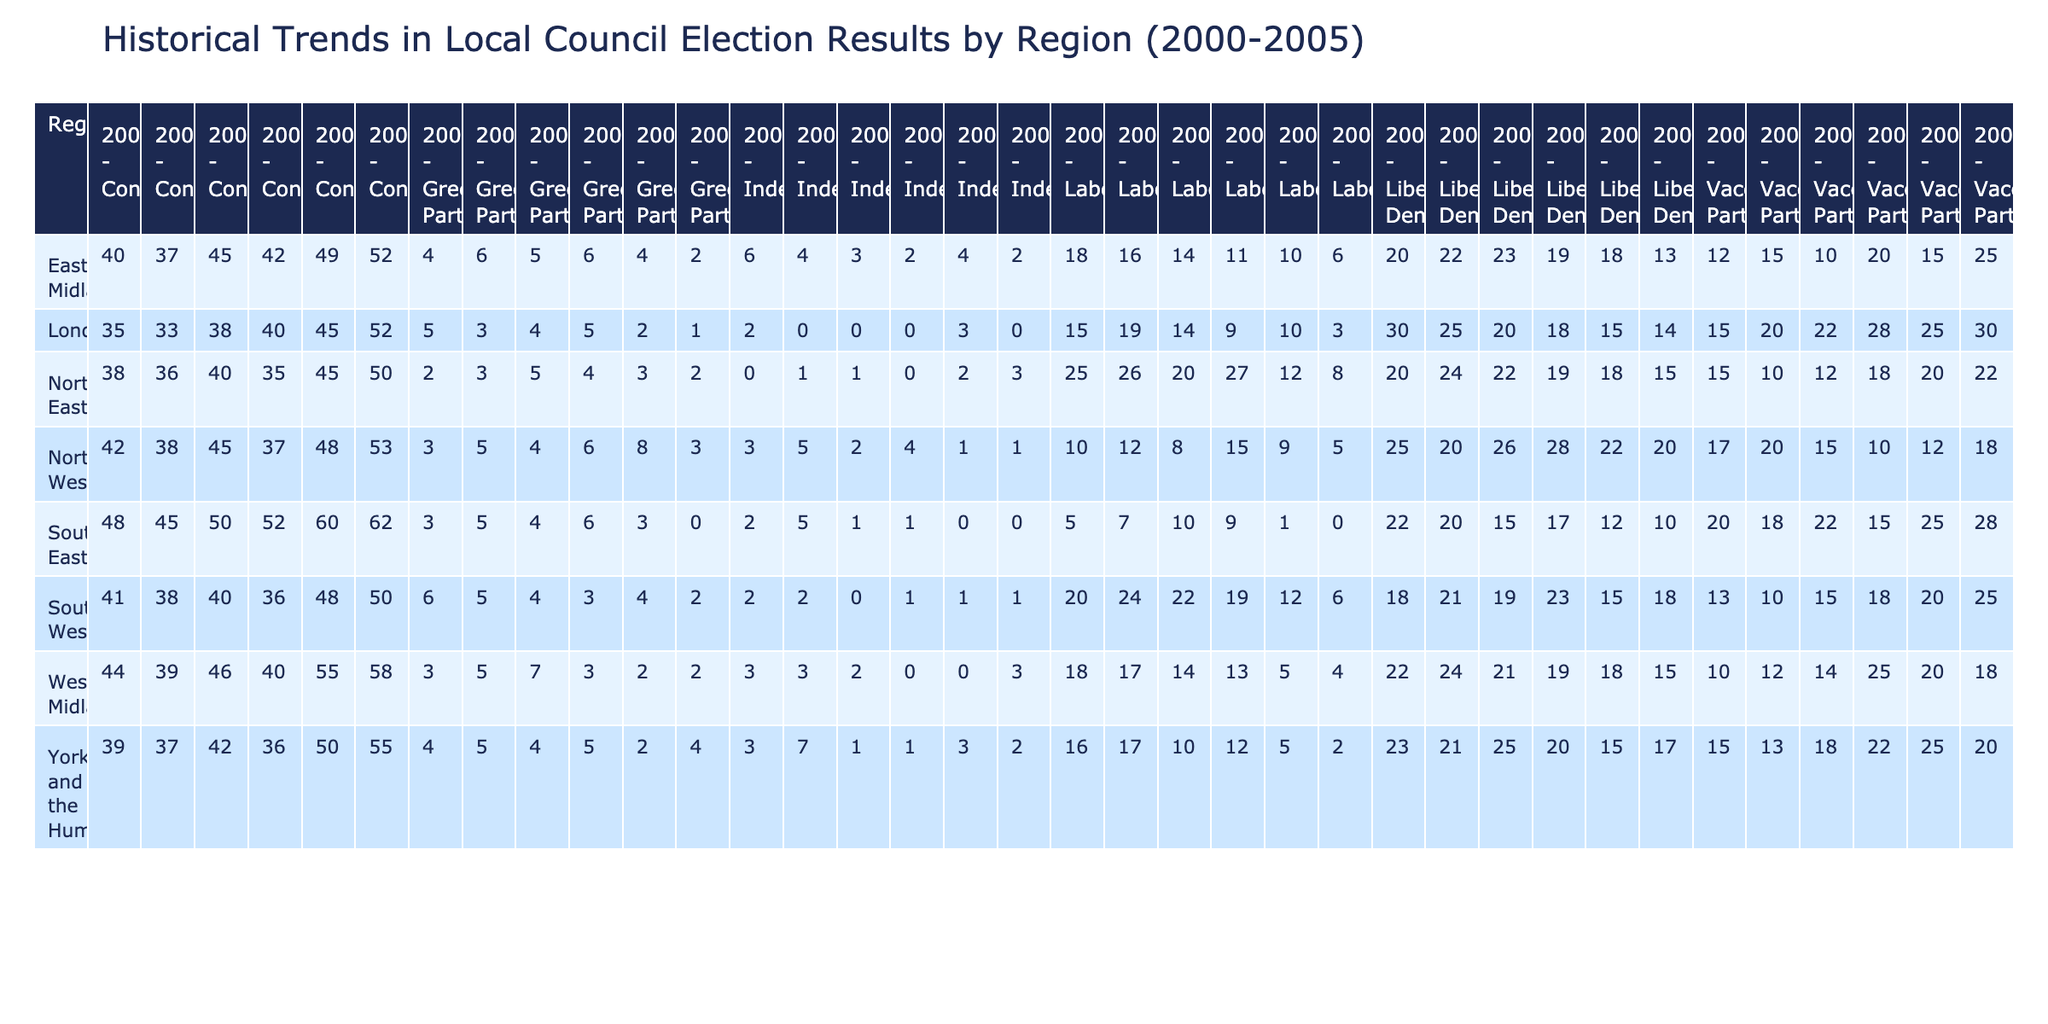What was the highest percentage of votes received by the Conservative Party in the North East region? In the North East region, the Conservative Party received the highest percentage of votes in 2005, which was 50%.
Answer: 50 Which party had the lowest percentage of votes in the West Midlands in 2004? In the West Midlands in 2004, the party with the lowest percentage of votes was the Independent, which received 0%.
Answer: 0 Did the Green Party ever receive more votes than the Vaccine Party in London between 2000 and 2005? By comparing the percentages in London from 2000 to 2005, the Green Party never exceeded the Vaccine Party’s votes. The highest for the Green Party was 5% in 2000, while the Vaccine Party peaked at 30% in the same year.
Answer: No What was the overall increase in percentage of Conservative votes from 2000 to 2005 in the South West region? In the South West region, the Conservative votes were 41% in 2000 and 50% in 2005. The increase is calculated as 50 - 41 = 9%.
Answer: 9 In which region did the Liberal Democrats have the most consistent percentage of votes from 2000 to 2005? Analyzing the percentages for the Liberal Democrats across all regions, the North East shows the most consistency. Their percentages are mostly within the low 20s, specifically 20% to 24%, indicating less fluctuation.
Answer: North East What was the average percentage of Labour votes in the Yorkshire and the Humber region over the years 2000 to 2005? The Labour percentages in Yorkshire and the Humber from 2000 to 2005 were 16, 17, 10, 12, 5, and 2. The average is calculated as (16 + 17 + 10 + 12 + 5 + 2) / 6 = 10.
Answer: 10 Did any region witness an increase in votes for the Green Party in every election year from 2000 to 2005? By reviewing the Green Party's votes in each region, no region consistently increased their percentage every year. The South West, for example, saw the Green Party's percentages fluctuate with a peak of 6% then decreasing in 2005.
Answer: No Which region saw the highest overall increase in percentage of votes for the Liberal Democrats from 2000 to 2005? Analyzing the Liberal Democrats' data, Yorkshire and the Humber shows the most notable increase with percentages rising from 23% in 2000 to 17% in 2005, indicating a decrease of 6% from their peak in 2004.
Answer: Yorkshire and the Humber 